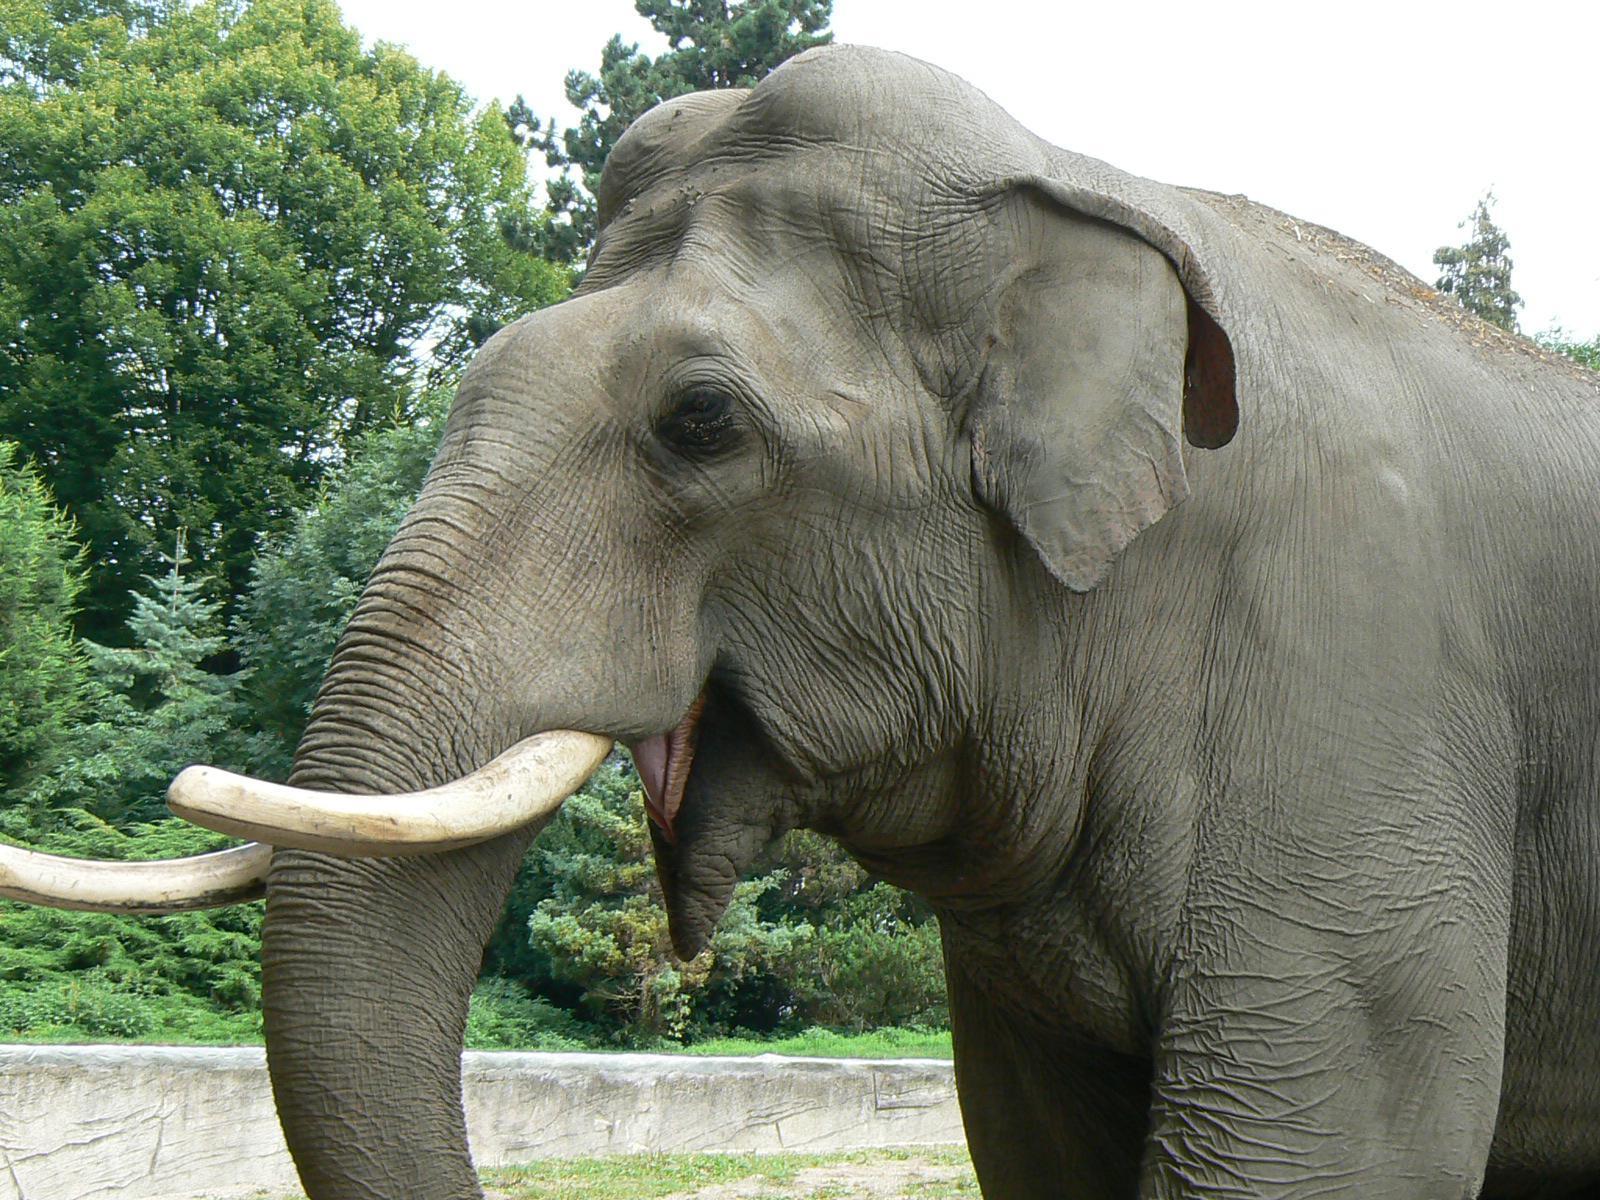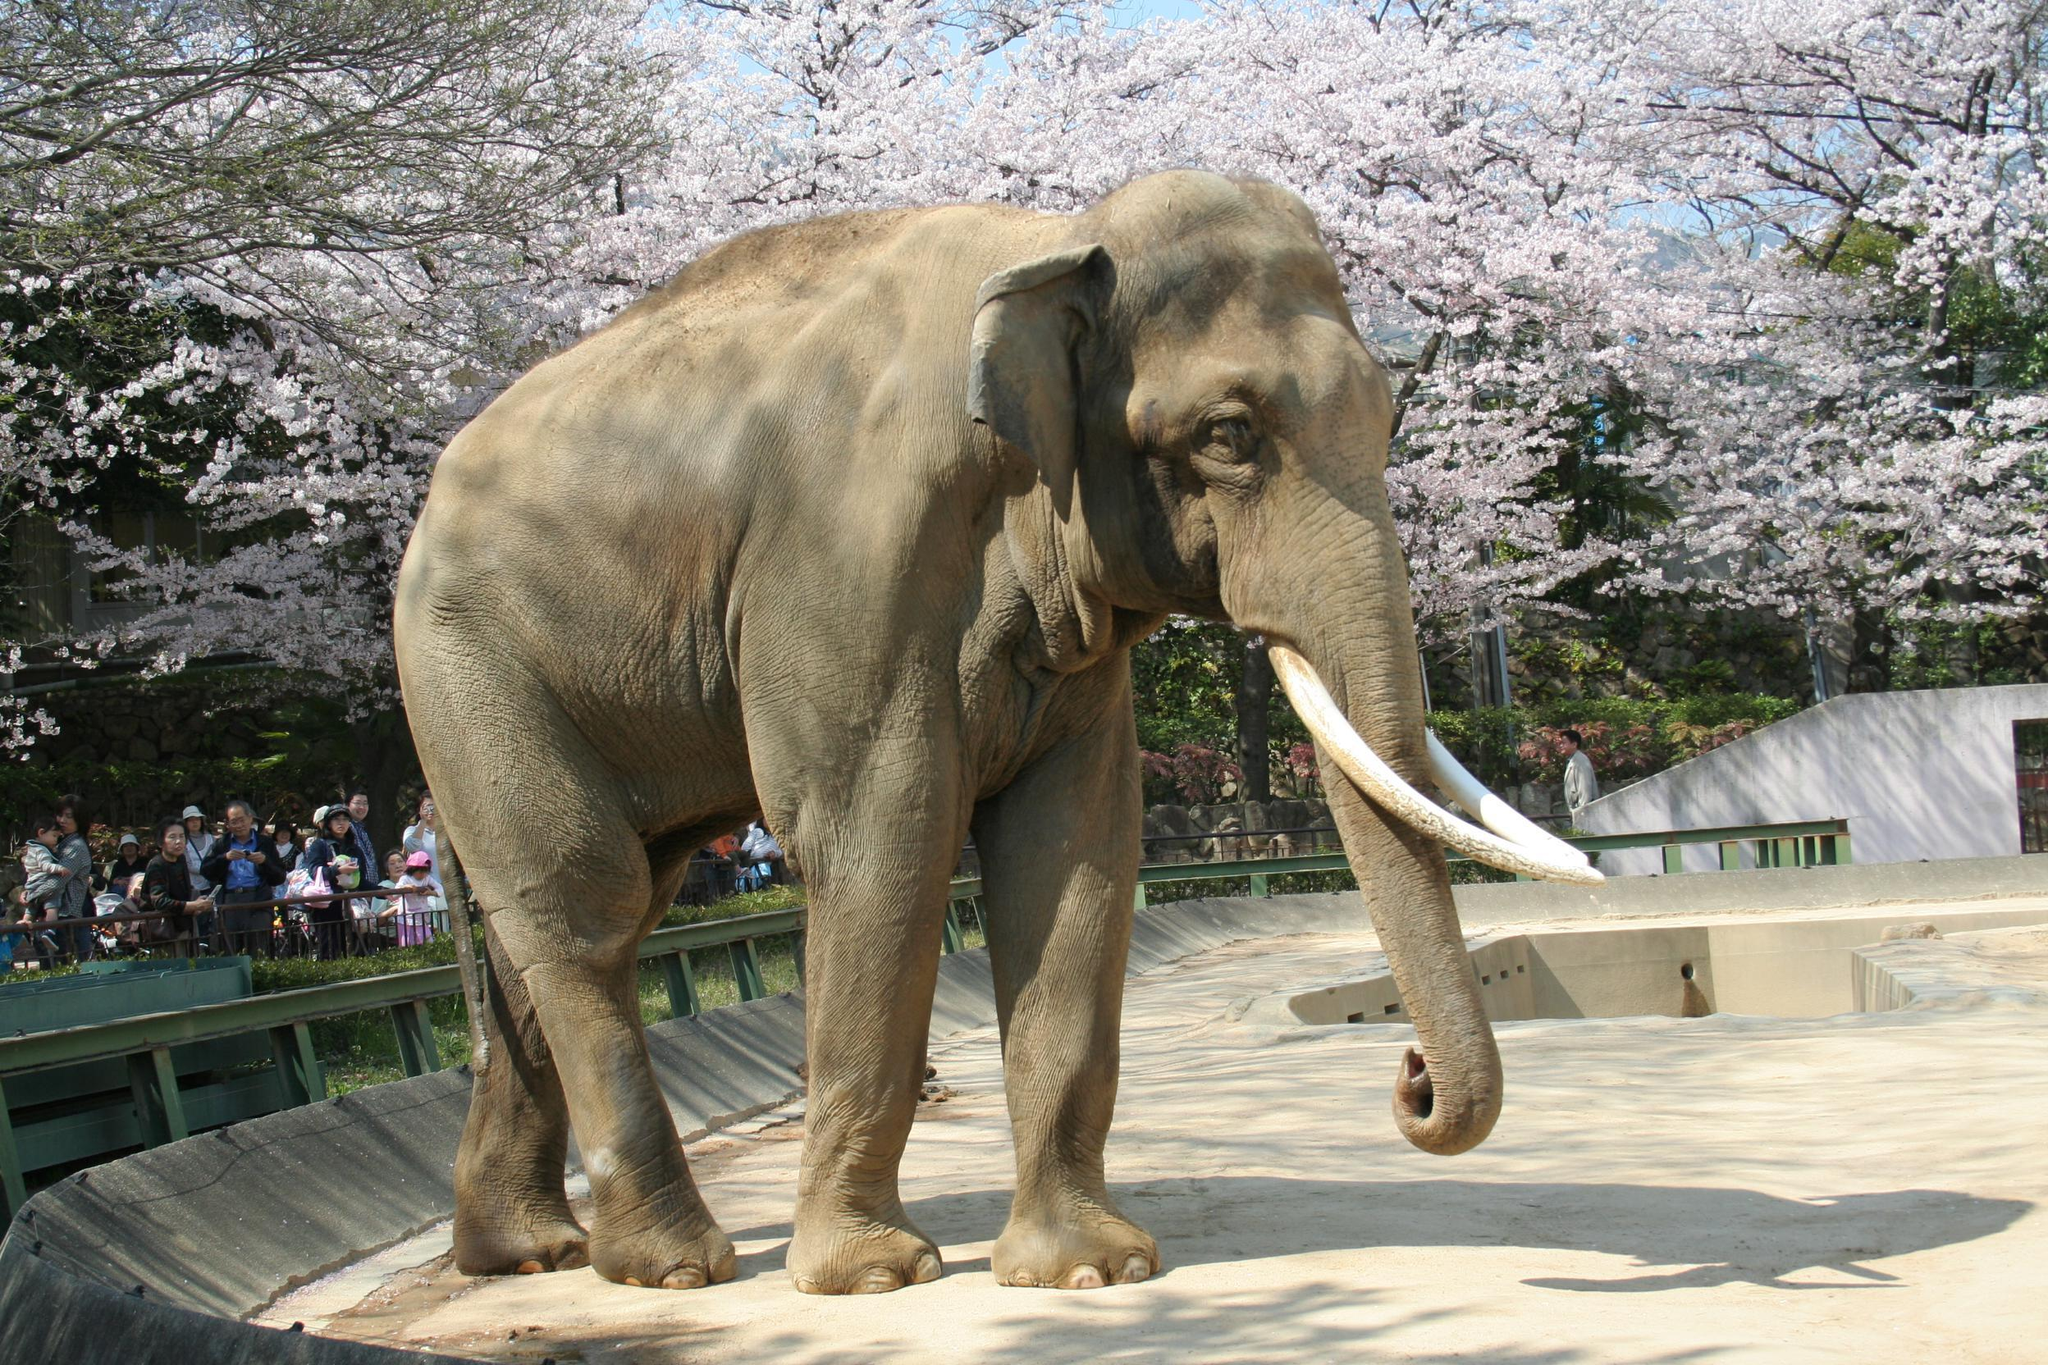The first image is the image on the left, the second image is the image on the right. For the images displayed, is the sentence "Exactly one adult elephant with long, white ivory tusks is depicted in each image." factually correct? Answer yes or no. Yes. The first image is the image on the left, the second image is the image on the right. For the images shown, is this caption "At least one elephant has it's trunk raised in one image." true? Answer yes or no. No. The first image is the image on the left, the second image is the image on the right. Considering the images on both sides, is "There is at least one elephant lifting its trunk in the air." valid? Answer yes or no. No. The first image is the image on the left, the second image is the image on the right. For the images displayed, is the sentence "Left and right images depict one elephant, which has tusks." factually correct? Answer yes or no. Yes. 